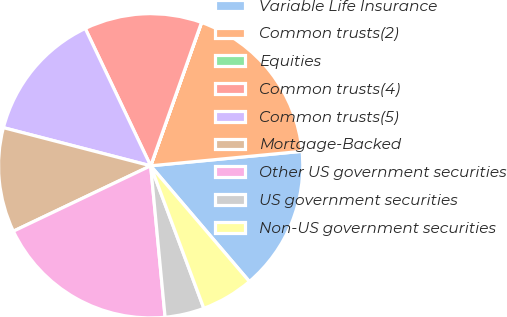<chart> <loc_0><loc_0><loc_500><loc_500><pie_chart><fcel>Variable Life Insurance<fcel>Common trusts(2)<fcel>Equities<fcel>Common trusts(4)<fcel>Common trusts(5)<fcel>Mortgage-Backed<fcel>Other US government securities<fcel>US government securities<fcel>Non-US government securities<nl><fcel>15.28%<fcel>18.05%<fcel>0.01%<fcel>12.5%<fcel>13.89%<fcel>11.11%<fcel>19.44%<fcel>4.17%<fcel>5.56%<nl></chart> 